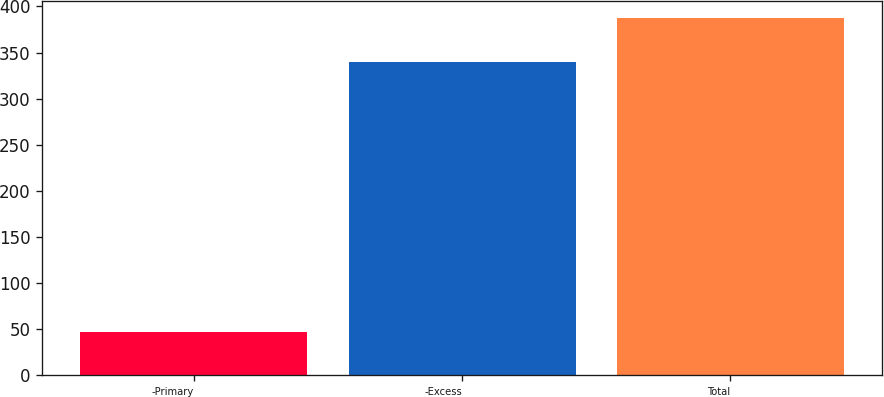Convert chart to OTSL. <chart><loc_0><loc_0><loc_500><loc_500><bar_chart><fcel>-Primary<fcel>-Excess<fcel>Total<nl><fcel>47<fcel>340<fcel>387<nl></chart> 